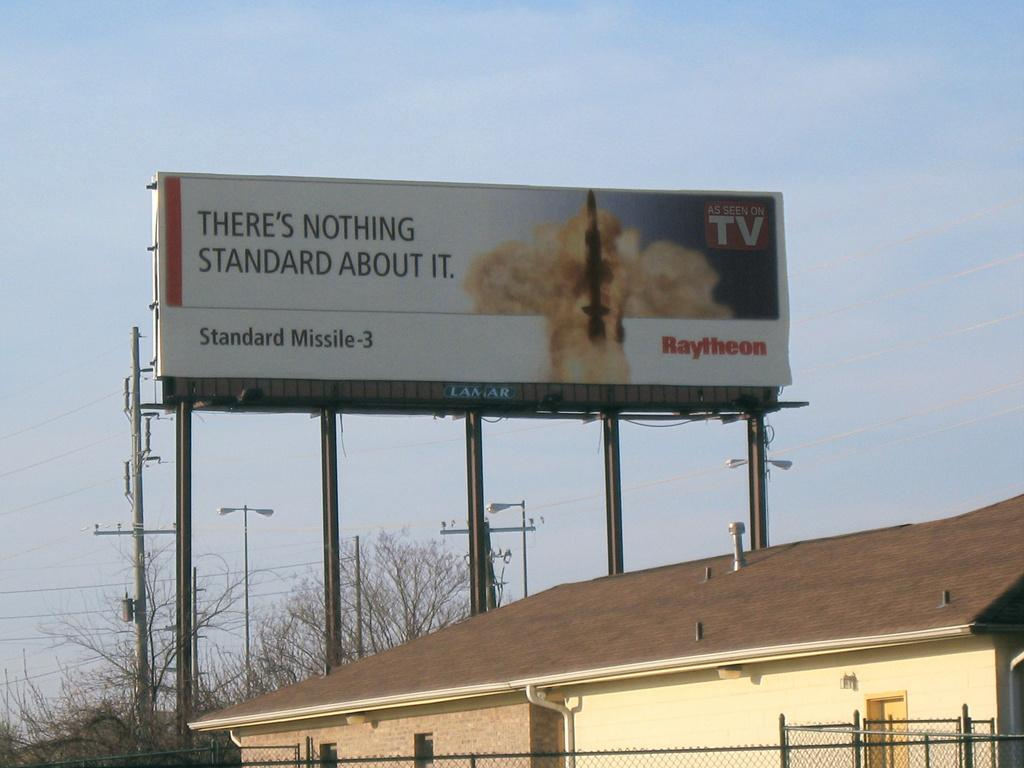<image>
Present a compact description of the photo's key features. A billboard above a building advertising something "as seen on TV." 